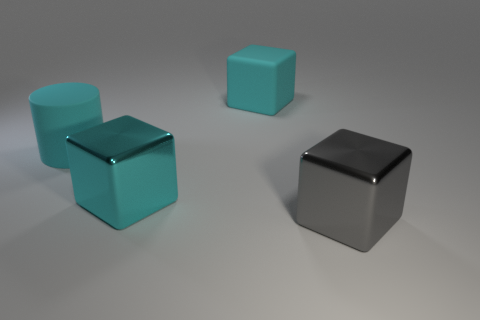Subtract all purple blocks. Subtract all yellow spheres. How many blocks are left? 3 Add 3 large red rubber spheres. How many objects exist? 7 Subtract all blocks. How many objects are left? 1 Subtract all large gray shiny cubes. Subtract all gray metal blocks. How many objects are left? 2 Add 3 large gray cubes. How many large gray cubes are left? 4 Add 1 tiny metallic cubes. How many tiny metallic cubes exist? 1 Subtract 0 blue blocks. How many objects are left? 4 